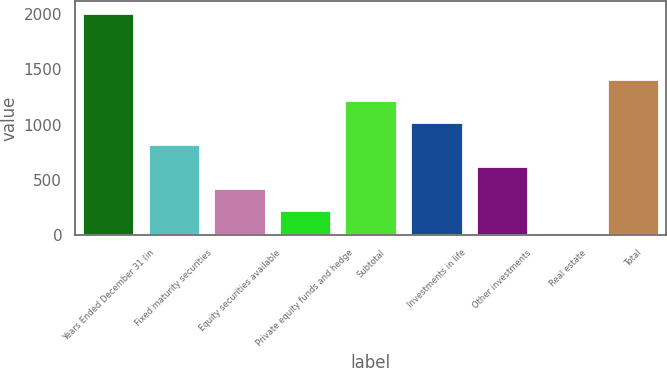Convert chart. <chart><loc_0><loc_0><loc_500><loc_500><bar_chart><fcel>Years Ended December 31 (in<fcel>Fixed maturity securities<fcel>Equity securities available<fcel>Private equity funds and hedge<fcel>Subtotal<fcel>Investments in life<fcel>Other investments<fcel>Real estate<fcel>Total<nl><fcel>2015<fcel>819.8<fcel>421.4<fcel>222.2<fcel>1218.2<fcel>1019<fcel>620.6<fcel>23<fcel>1417.4<nl></chart> 